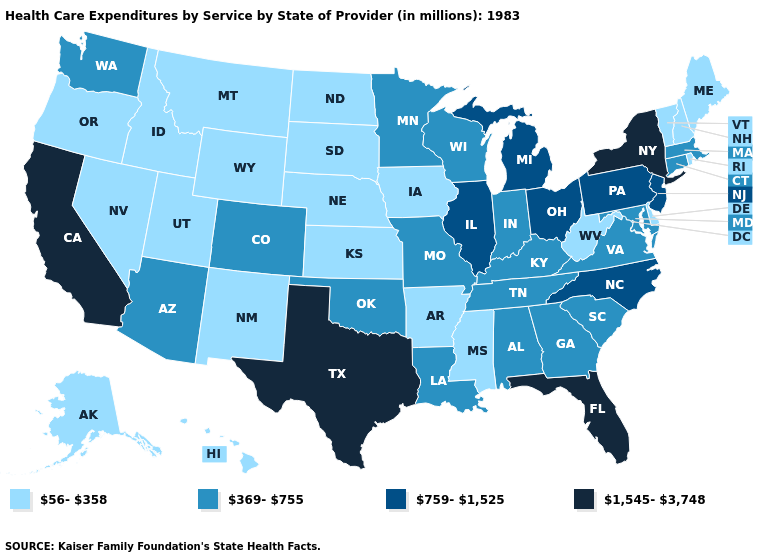Name the states that have a value in the range 369-755?
Be succinct. Alabama, Arizona, Colorado, Connecticut, Georgia, Indiana, Kentucky, Louisiana, Maryland, Massachusetts, Minnesota, Missouri, Oklahoma, South Carolina, Tennessee, Virginia, Washington, Wisconsin. Does Florida have the highest value in the USA?
Write a very short answer. Yes. What is the value of Illinois?
Keep it brief. 759-1,525. Does Oregon have the lowest value in the West?
Concise answer only. Yes. What is the value of Alaska?
Be succinct. 56-358. Does Delaware have the highest value in the USA?
Write a very short answer. No. What is the lowest value in states that border Montana?
Short answer required. 56-358. Which states have the highest value in the USA?
Quick response, please. California, Florida, New York, Texas. Does the map have missing data?
Quick response, please. No. What is the value of New York?
Write a very short answer. 1,545-3,748. What is the lowest value in the West?
Short answer required. 56-358. How many symbols are there in the legend?
Write a very short answer. 4. Does Ohio have a lower value than Delaware?
Quick response, please. No. 